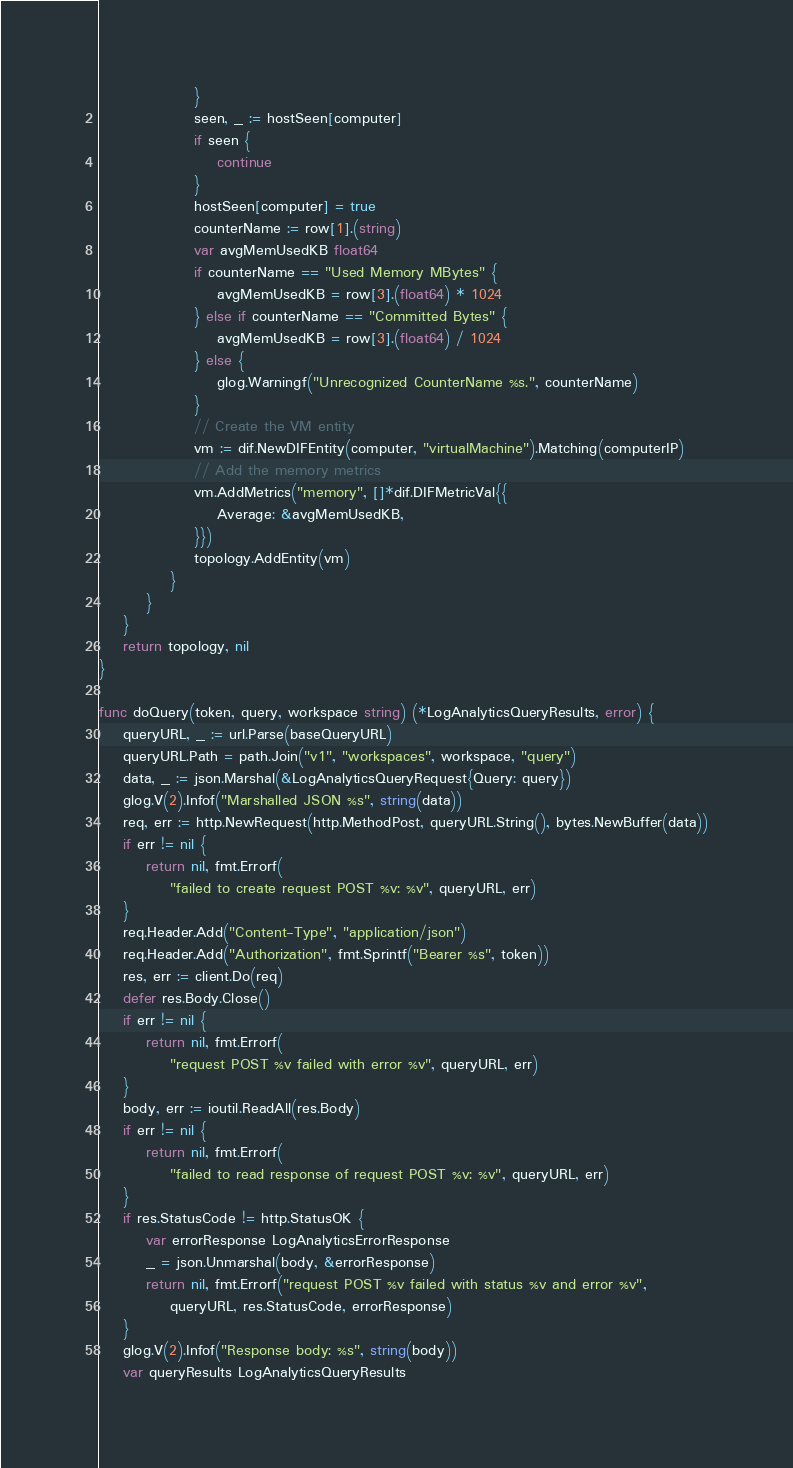<code> <loc_0><loc_0><loc_500><loc_500><_Go_>				}
				seen, _ := hostSeen[computer]
				if seen {
					continue
				}
				hostSeen[computer] = true
				counterName := row[1].(string)
				var avgMemUsedKB float64
				if counterName == "Used Memory MBytes" {
					avgMemUsedKB = row[3].(float64) * 1024
				} else if counterName == "Committed Bytes" {
					avgMemUsedKB = row[3].(float64) / 1024
				} else {
					glog.Warningf("Unrecognized CounterName %s.", counterName)
				}
				// Create the VM entity
				vm := dif.NewDIFEntity(computer, "virtualMachine").Matching(computerIP)
				// Add the memory metrics
				vm.AddMetrics("memory", []*dif.DIFMetricVal{{
					Average: &avgMemUsedKB,
				}})
				topology.AddEntity(vm)
			}
		}
	}
	return topology, nil
}

func doQuery(token, query, workspace string) (*LogAnalyticsQueryResults, error) {
	queryURL, _ := url.Parse(baseQueryURL)
	queryURL.Path = path.Join("v1", "workspaces", workspace, "query")
	data, _ := json.Marshal(&LogAnalyticsQueryRequest{Query: query})
	glog.V(2).Infof("Marshalled JSON %s", string(data))
	req, err := http.NewRequest(http.MethodPost, queryURL.String(), bytes.NewBuffer(data))
	if err != nil {
		return nil, fmt.Errorf(
			"failed to create request POST %v: %v", queryURL, err)
	}
	req.Header.Add("Content-Type", "application/json")
	req.Header.Add("Authorization", fmt.Sprintf("Bearer %s", token))
	res, err := client.Do(req)
	defer res.Body.Close()
	if err != nil {
		return nil, fmt.Errorf(
			"request POST %v failed with error %v", queryURL, err)
	}
	body, err := ioutil.ReadAll(res.Body)
	if err != nil {
		return nil, fmt.Errorf(
			"failed to read response of request POST %v: %v", queryURL, err)
	}
	if res.StatusCode != http.StatusOK {
		var errorResponse LogAnalyticsErrorResponse
		_ = json.Unmarshal(body, &errorResponse)
		return nil, fmt.Errorf("request POST %v failed with status %v and error %v",
			queryURL, res.StatusCode, errorResponse)
	}
	glog.V(2).Infof("Response body: %s", string(body))
	var queryResults LogAnalyticsQueryResults</code> 